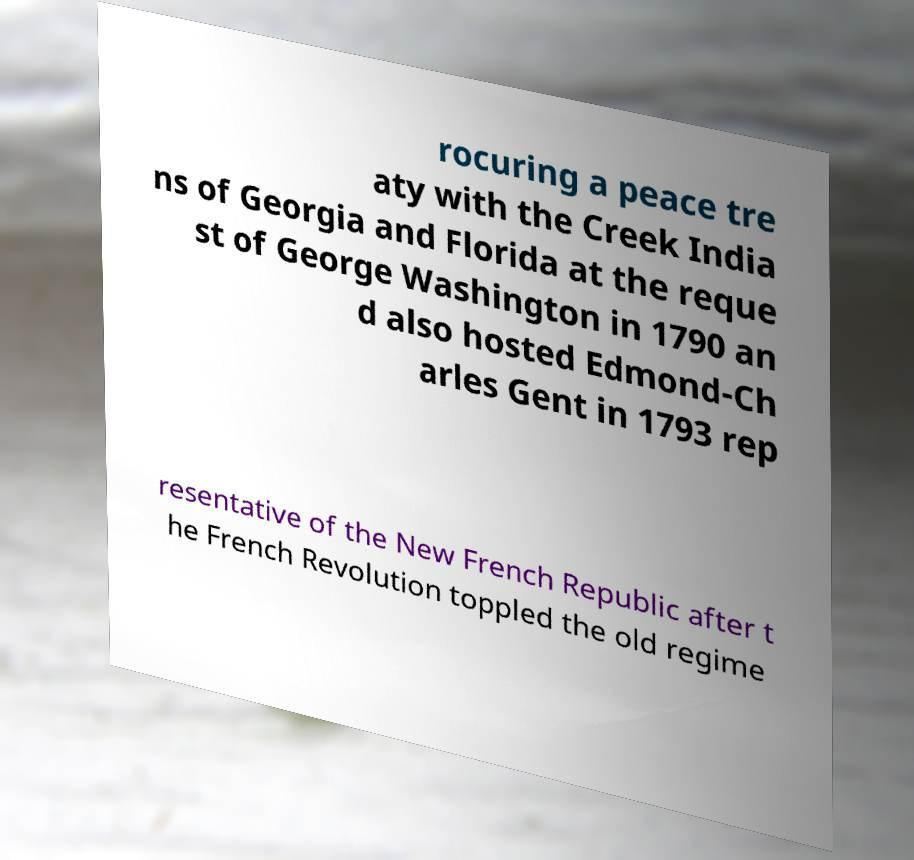Please read and relay the text visible in this image. What does it say? rocuring a peace tre aty with the Creek India ns of Georgia and Florida at the reque st of George Washington in 1790 an d also hosted Edmond-Ch arles Gent in 1793 rep resentative of the New French Republic after t he French Revolution toppled the old regime 